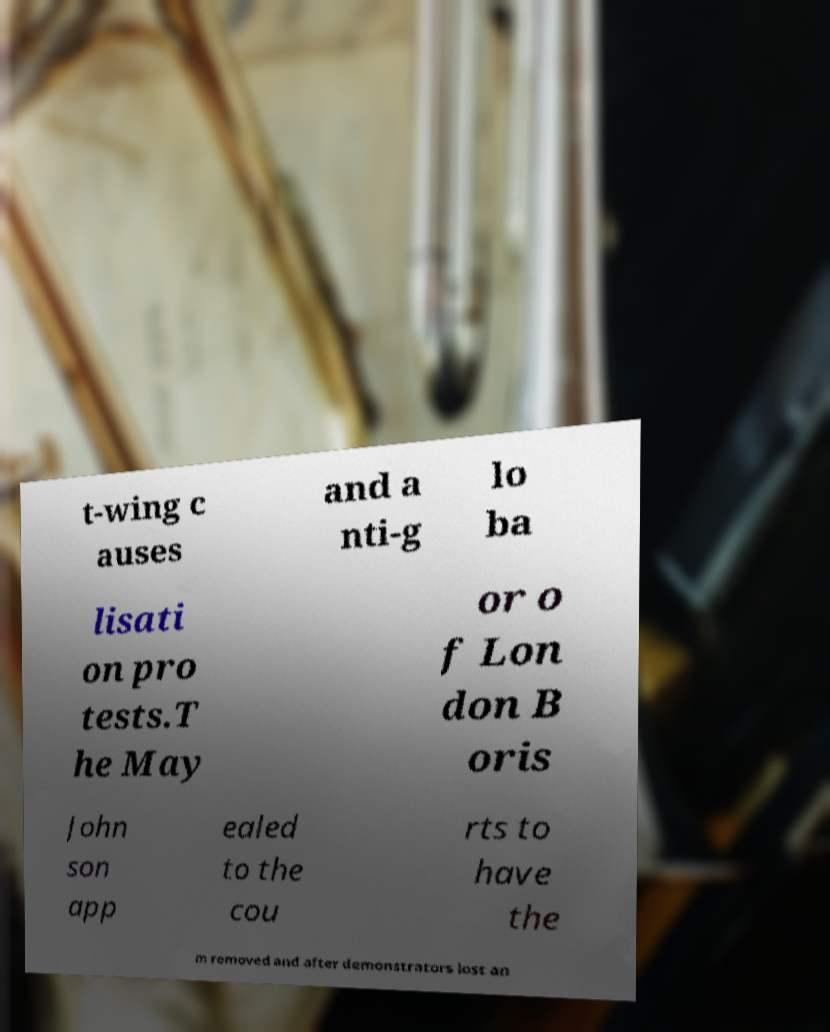I need the written content from this picture converted into text. Can you do that? t-wing c auses and a nti-g lo ba lisati on pro tests.T he May or o f Lon don B oris John son app ealed to the cou rts to have the m removed and after demonstrators lost an 